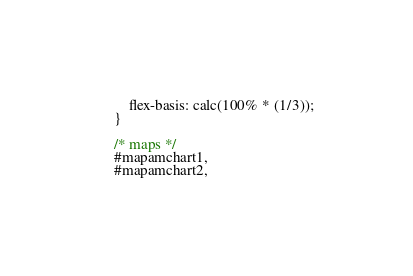<code> <loc_0><loc_0><loc_500><loc_500><_CSS_>        flex-basis: calc(100% * (1/3));
    }

    /* maps */
    #mapamchart1,
    #mapamchart2,</code> 